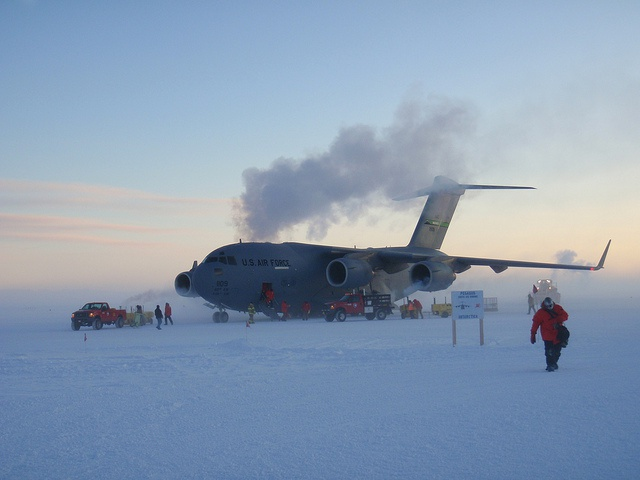Describe the objects in this image and their specific colors. I can see airplane in gray, navy, darkblue, and black tones, truck in gray, black, darkblue, and purple tones, people in gray, black, maroon, and navy tones, truck in gray, black, purple, and blue tones, and truck in gray and darkblue tones in this image. 